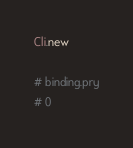Convert code to text. <code><loc_0><loc_0><loc_500><loc_500><_Ruby_>
Cli.new

# binding.pry
# 0
</code> 